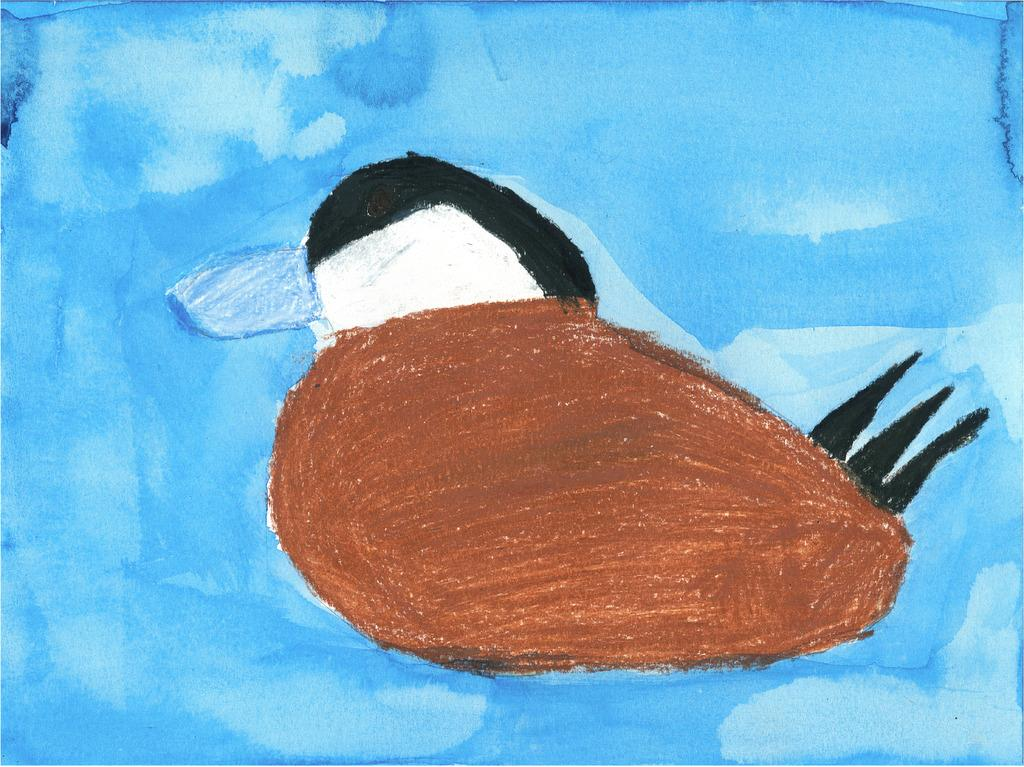What is depicted in the painting in the image? There is a painting of a bird in the image. What color is the background of the painting? The background of the painting is blue. How many tomatoes are on the table in the painting? There are no tomatoes present in the image, as the image only features a painting of a bird with a blue background. 